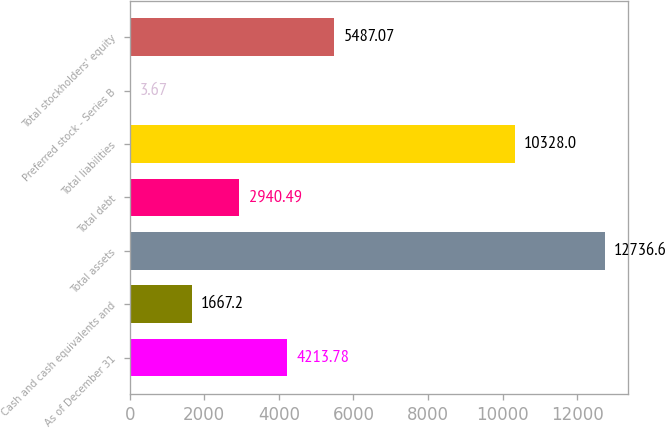<chart> <loc_0><loc_0><loc_500><loc_500><bar_chart><fcel>As of December 31<fcel>Cash and cash equivalents and<fcel>Total assets<fcel>Total debt<fcel>Total liabilities<fcel>Preferred stock - Series B<fcel>Total stockholders' equity<nl><fcel>4213.78<fcel>1667.2<fcel>12736.6<fcel>2940.49<fcel>10328<fcel>3.67<fcel>5487.07<nl></chart> 